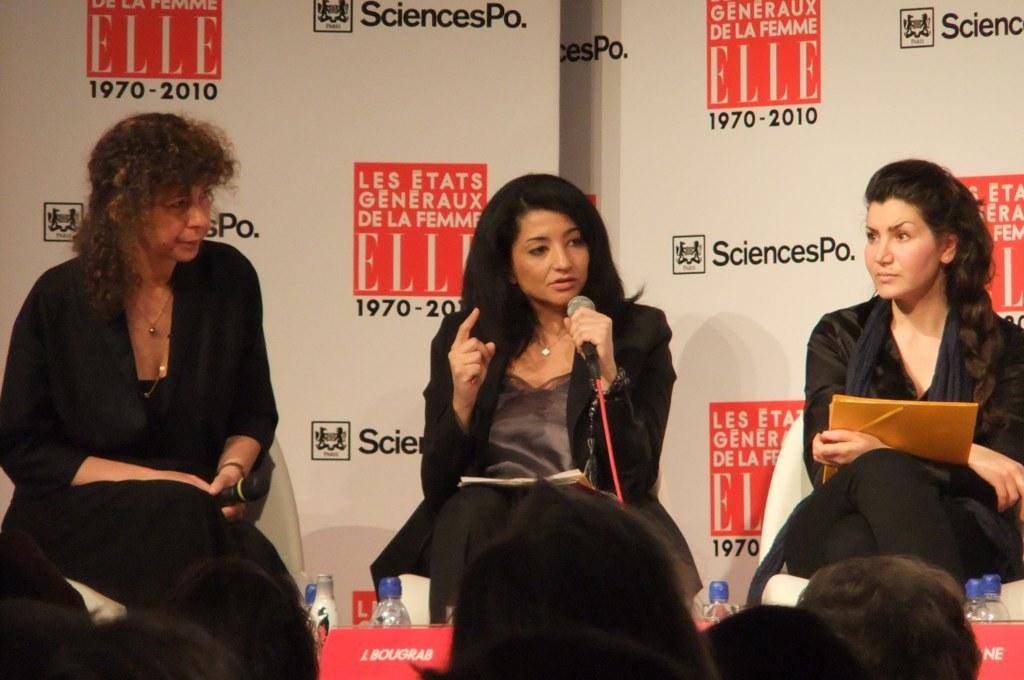Can you describe this image briefly? In the image I can see three women are sitting among them women on the left side are holding microphones in hands and the woman on the right side is holding some object in hands. These women are wearing black color clothes. In front of the image I can see people, bottles and some other objects. 